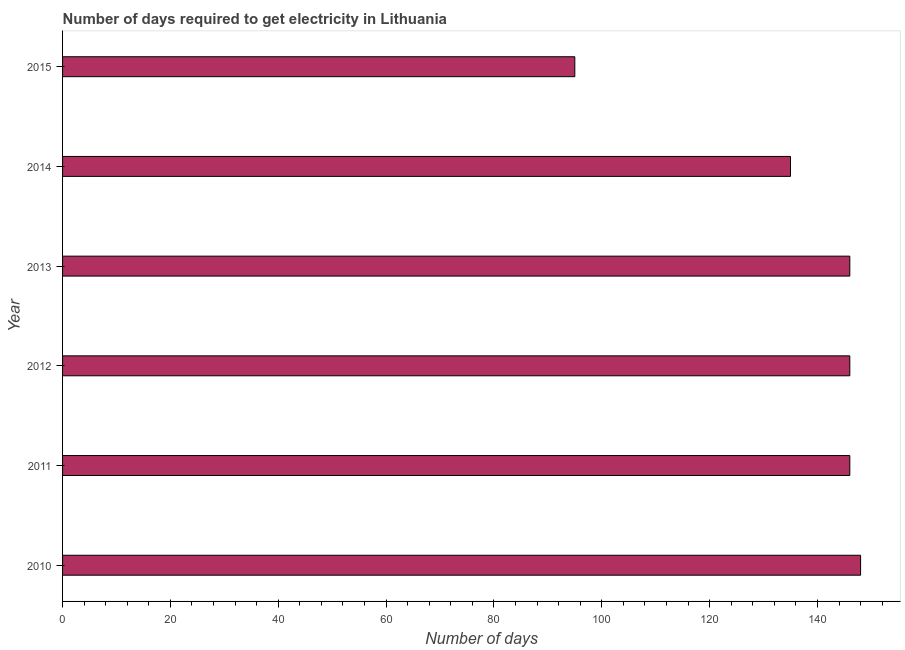Does the graph contain any zero values?
Provide a short and direct response. No. What is the title of the graph?
Your answer should be very brief. Number of days required to get electricity in Lithuania. What is the label or title of the X-axis?
Make the answer very short. Number of days. What is the label or title of the Y-axis?
Your answer should be compact. Year. What is the time to get electricity in 2010?
Provide a short and direct response. 148. Across all years, what is the maximum time to get electricity?
Keep it short and to the point. 148. In which year was the time to get electricity maximum?
Your answer should be compact. 2010. In which year was the time to get electricity minimum?
Give a very brief answer. 2015. What is the sum of the time to get electricity?
Your response must be concise. 816. What is the difference between the time to get electricity in 2012 and 2015?
Your answer should be compact. 51. What is the average time to get electricity per year?
Make the answer very short. 136. What is the median time to get electricity?
Your answer should be very brief. 146. In how many years, is the time to get electricity greater than 8 ?
Your answer should be very brief. 6. What is the ratio of the time to get electricity in 2012 to that in 2015?
Offer a very short reply. 1.54. Is the time to get electricity in 2011 less than that in 2014?
Ensure brevity in your answer.  No. Is the sum of the time to get electricity in 2010 and 2015 greater than the maximum time to get electricity across all years?
Your answer should be very brief. Yes. What is the difference between the highest and the lowest time to get electricity?
Your answer should be very brief. 53. Are all the bars in the graph horizontal?
Make the answer very short. Yes. Are the values on the major ticks of X-axis written in scientific E-notation?
Offer a terse response. No. What is the Number of days in 2010?
Provide a succinct answer. 148. What is the Number of days in 2011?
Your answer should be compact. 146. What is the Number of days of 2012?
Your answer should be compact. 146. What is the Number of days in 2013?
Your answer should be compact. 146. What is the Number of days of 2014?
Provide a short and direct response. 135. What is the Number of days of 2015?
Your answer should be very brief. 95. What is the difference between the Number of days in 2010 and 2012?
Your answer should be very brief. 2. What is the difference between the Number of days in 2010 and 2014?
Offer a very short reply. 13. What is the difference between the Number of days in 2010 and 2015?
Ensure brevity in your answer.  53. What is the difference between the Number of days in 2011 and 2013?
Provide a short and direct response. 0. What is the difference between the Number of days in 2012 and 2013?
Provide a short and direct response. 0. What is the difference between the Number of days in 2012 and 2014?
Your answer should be compact. 11. What is the difference between the Number of days in 2014 and 2015?
Offer a very short reply. 40. What is the ratio of the Number of days in 2010 to that in 2014?
Keep it short and to the point. 1.1. What is the ratio of the Number of days in 2010 to that in 2015?
Keep it short and to the point. 1.56. What is the ratio of the Number of days in 2011 to that in 2014?
Keep it short and to the point. 1.08. What is the ratio of the Number of days in 2011 to that in 2015?
Keep it short and to the point. 1.54. What is the ratio of the Number of days in 2012 to that in 2014?
Your response must be concise. 1.08. What is the ratio of the Number of days in 2012 to that in 2015?
Keep it short and to the point. 1.54. What is the ratio of the Number of days in 2013 to that in 2014?
Your response must be concise. 1.08. What is the ratio of the Number of days in 2013 to that in 2015?
Offer a terse response. 1.54. What is the ratio of the Number of days in 2014 to that in 2015?
Give a very brief answer. 1.42. 